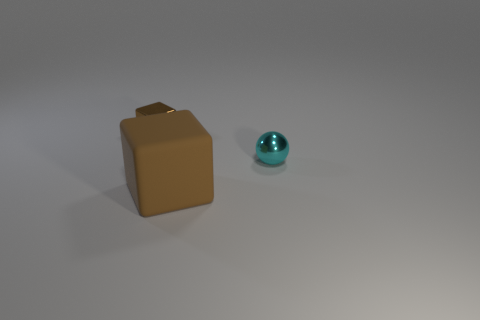Add 2 red objects. How many objects exist? 5 Subtract all blocks. How many objects are left? 1 Add 1 small cyan shiny spheres. How many small cyan shiny spheres exist? 2 Subtract 0 gray blocks. How many objects are left? 3 Subtract all blue blocks. Subtract all purple spheres. How many blocks are left? 2 Subtract all big red cubes. Subtract all brown blocks. How many objects are left? 1 Add 1 cyan objects. How many cyan objects are left? 2 